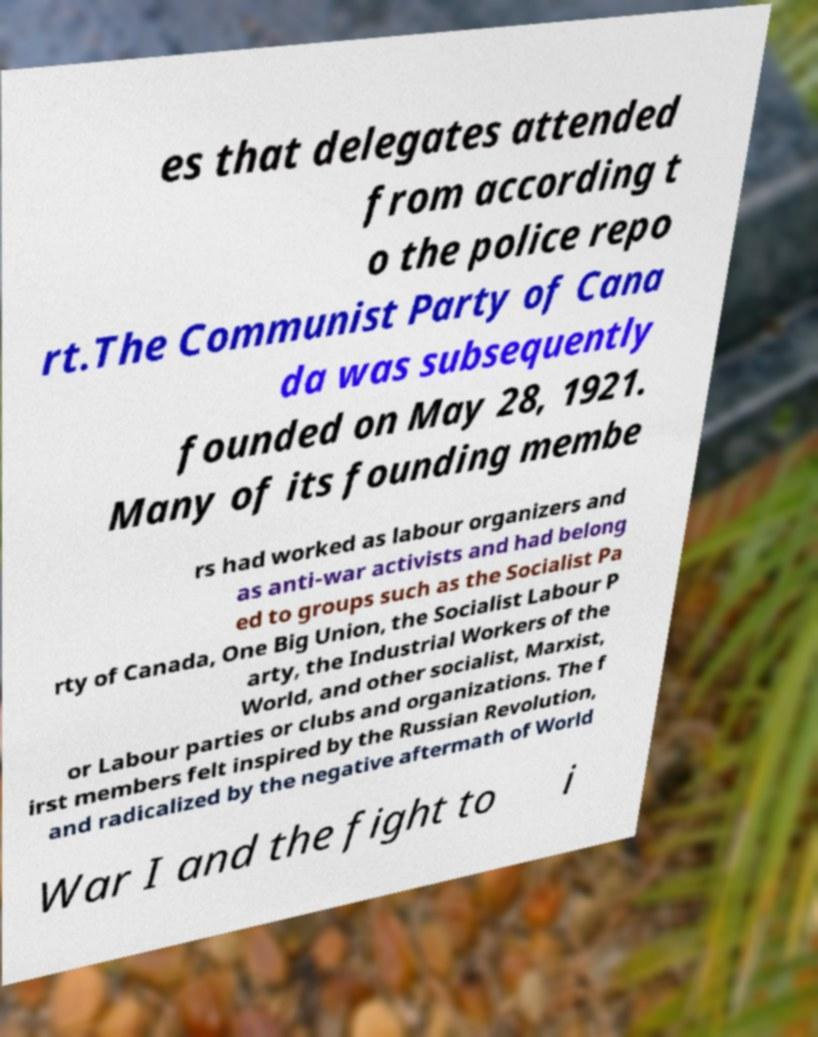Can you read and provide the text displayed in the image?This photo seems to have some interesting text. Can you extract and type it out for me? es that delegates attended from according t o the police repo rt.The Communist Party of Cana da was subsequently founded on May 28, 1921. Many of its founding membe rs had worked as labour organizers and as anti-war activists and had belong ed to groups such as the Socialist Pa rty of Canada, One Big Union, the Socialist Labour P arty, the Industrial Workers of the World, and other socialist, Marxist, or Labour parties or clubs and organizations. The f irst members felt inspired by the Russian Revolution, and radicalized by the negative aftermath of World War I and the fight to i 